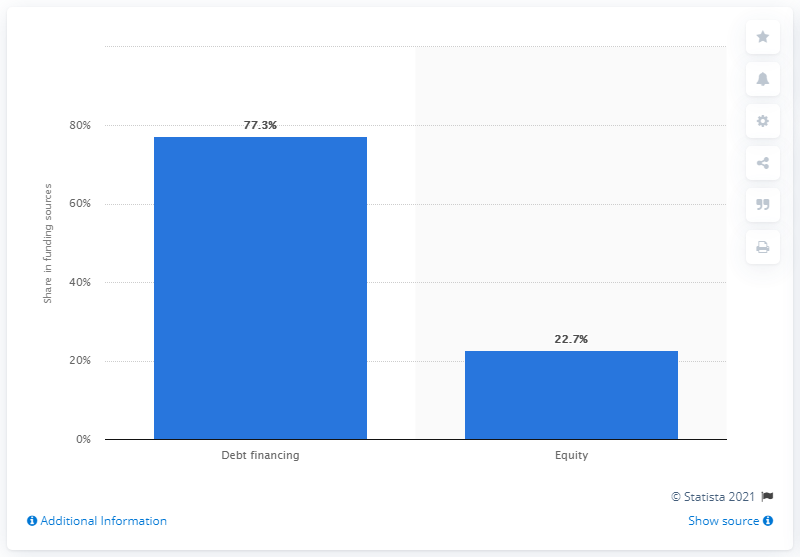Point out several critical features in this image. In Bulgaria, 77.3% of the funding structure of micro-lending institutions was derived from debt financing. 